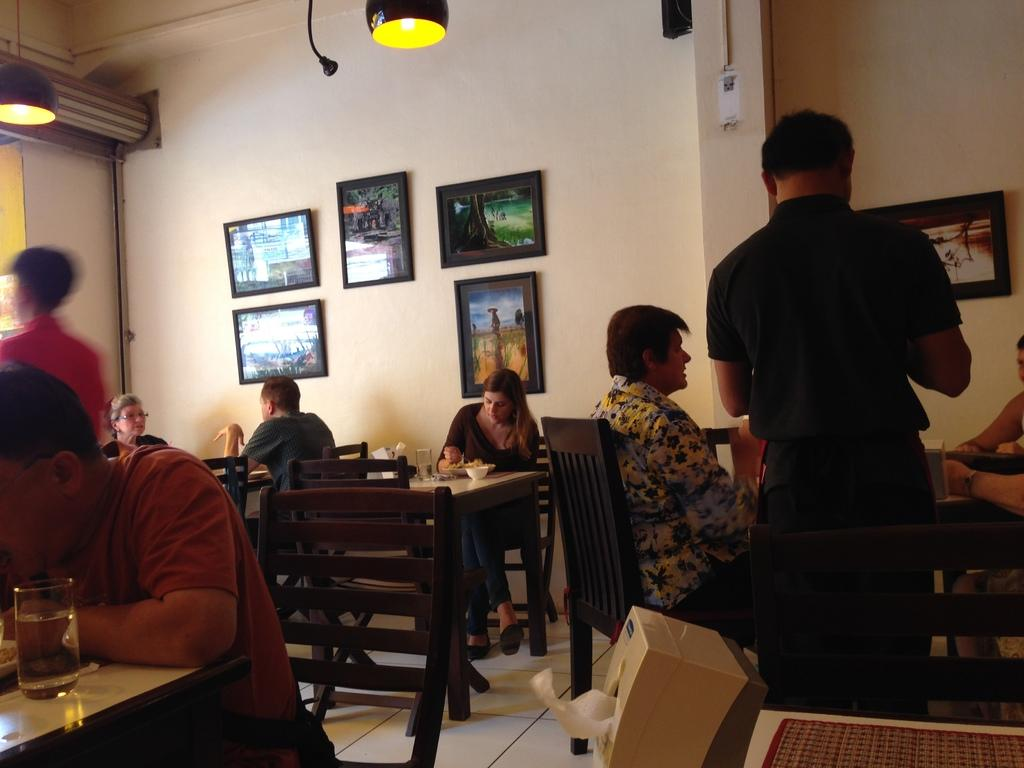What are the people in the image doing? The persons in the image are sitting on chairs. What is present in the image besides the people? There is a table in the image. What is on the table? There is a glass on the table. What can be seen on the wall? There are photo frames on the wall. What is providing light in the image? There is a light above the scene. Can you see a snake slithering across the table in the image? No, there is no snake present in the image. What type of plate is being used by the people in the image? There is no plate visible in the image; only a glass is present on the table. 